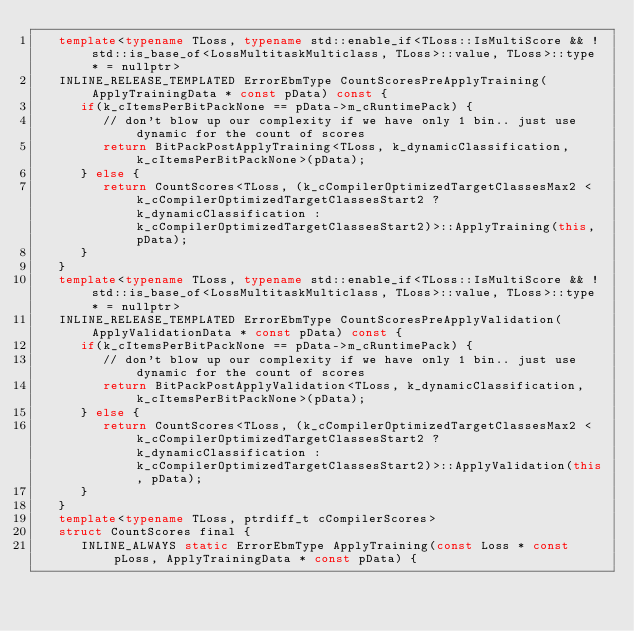<code> <loc_0><loc_0><loc_500><loc_500><_C++_>   template<typename TLoss, typename std::enable_if<TLoss::IsMultiScore && !std::is_base_of<LossMultitaskMulticlass, TLoss>::value, TLoss>::type * = nullptr>
   INLINE_RELEASE_TEMPLATED ErrorEbmType CountScoresPreApplyTraining(ApplyTrainingData * const pData) const {
      if(k_cItemsPerBitPackNone == pData->m_cRuntimePack) {
         // don't blow up our complexity if we have only 1 bin.. just use dynamic for the count of scores
         return BitPackPostApplyTraining<TLoss, k_dynamicClassification, k_cItemsPerBitPackNone>(pData);
      } else {
         return CountScores<TLoss, (k_cCompilerOptimizedTargetClassesMax2 < k_cCompilerOptimizedTargetClassesStart2 ? k_dynamicClassification : k_cCompilerOptimizedTargetClassesStart2)>::ApplyTraining(this, pData);
      }
   }
   template<typename TLoss, typename std::enable_if<TLoss::IsMultiScore && !std::is_base_of<LossMultitaskMulticlass, TLoss>::value, TLoss>::type * = nullptr>
   INLINE_RELEASE_TEMPLATED ErrorEbmType CountScoresPreApplyValidation(ApplyValidationData * const pData) const {
      if(k_cItemsPerBitPackNone == pData->m_cRuntimePack) {
         // don't blow up our complexity if we have only 1 bin.. just use dynamic for the count of scores
         return BitPackPostApplyValidation<TLoss, k_dynamicClassification, k_cItemsPerBitPackNone>(pData);
      } else {
         return CountScores<TLoss, (k_cCompilerOptimizedTargetClassesMax2 < k_cCompilerOptimizedTargetClassesStart2 ? k_dynamicClassification : k_cCompilerOptimizedTargetClassesStart2)>::ApplyValidation(this, pData);
      }
   }
   template<typename TLoss, ptrdiff_t cCompilerScores>
   struct CountScores final {
      INLINE_ALWAYS static ErrorEbmType ApplyTraining(const Loss * const pLoss, ApplyTrainingData * const pData) {</code> 